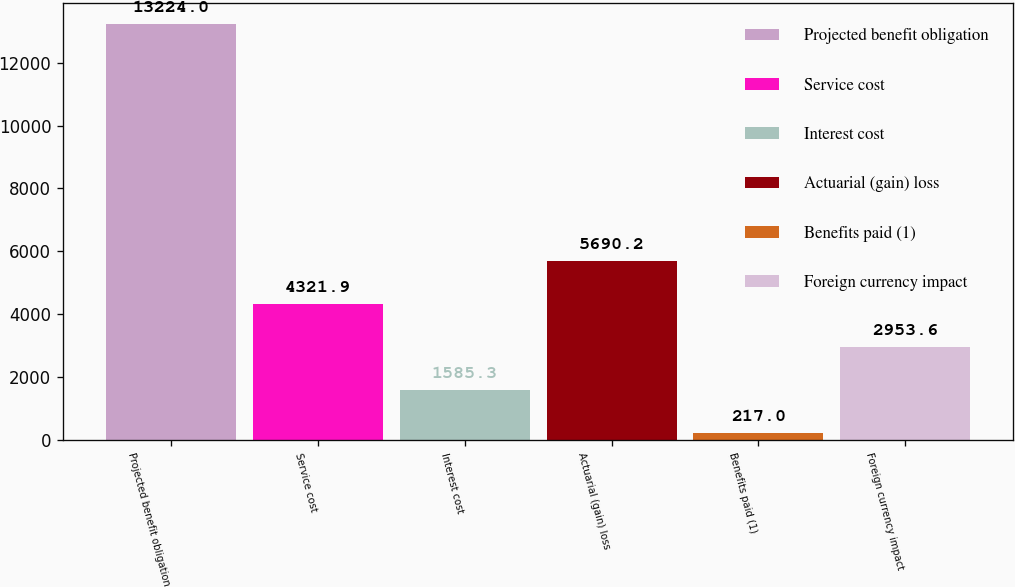Convert chart to OTSL. <chart><loc_0><loc_0><loc_500><loc_500><bar_chart><fcel>Projected benefit obligation<fcel>Service cost<fcel>Interest cost<fcel>Actuarial (gain) loss<fcel>Benefits paid (1)<fcel>Foreign currency impact<nl><fcel>13224<fcel>4321.9<fcel>1585.3<fcel>5690.2<fcel>217<fcel>2953.6<nl></chart> 